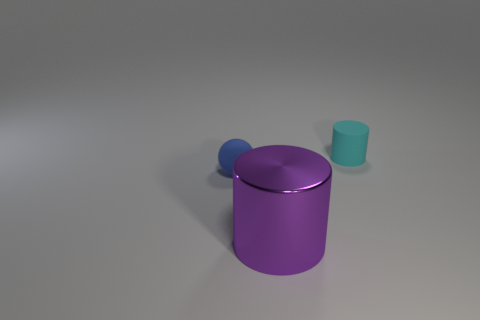What is the material of the object to the right of the metallic thing?
Make the answer very short. Rubber. How many small cylinders are the same color as the large thing?
Offer a very short reply. 0. What size is the cyan cylinder that is the same material as the blue thing?
Make the answer very short. Small. What number of things are purple metallic cylinders or small green objects?
Provide a succinct answer. 1. What is the color of the rubber object that is to the left of the big purple metallic cylinder?
Your answer should be very brief. Blue. What is the size of the other thing that is the same shape as the cyan rubber object?
Your answer should be very brief. Large. What number of objects are small rubber objects behind the small blue ball or tiny matte things right of the rubber sphere?
Give a very brief answer. 1. There is a thing that is both in front of the tiny cyan thing and behind the big cylinder; what size is it?
Your answer should be compact. Small. There is a purple metallic object; is its shape the same as the blue object that is behind the shiny object?
Offer a very short reply. No. What number of things are either small objects that are to the left of the small cylinder or cyan cylinders?
Keep it short and to the point. 2. 